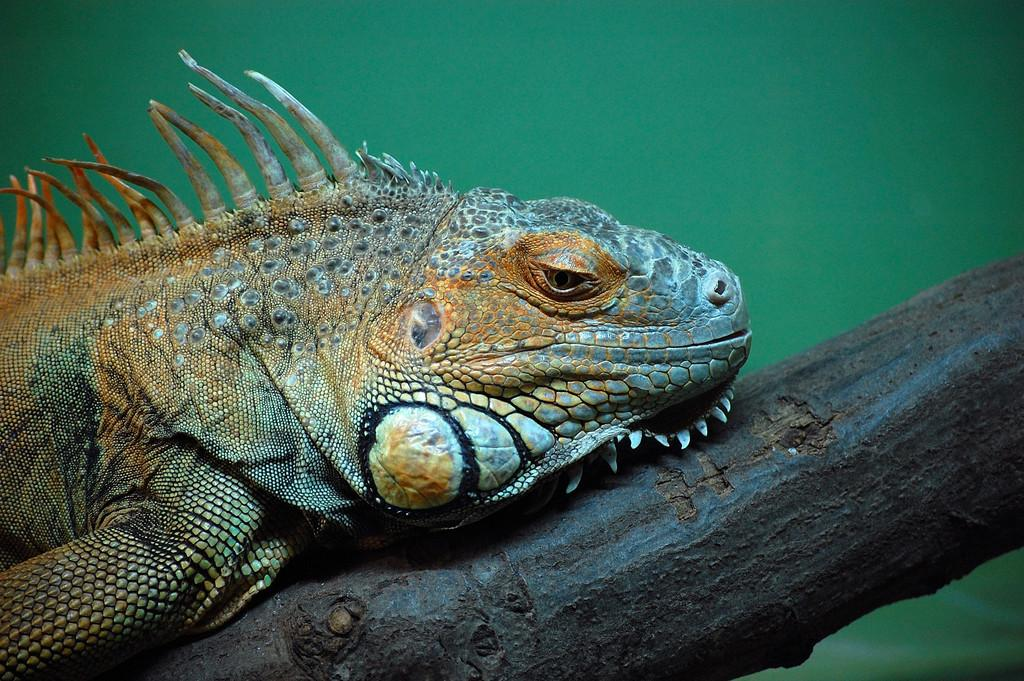What type of animal is in the image? There is a reptile in the image. Where is the reptile located? The reptile is on a wooden log. What color is the background of the image? The background of the image is green. Can you see a drain in the image? There is no drain present in the image. Is the reptile biting the wooden log in the image? The image does not show the reptile biting the wooden log. 